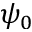<formula> <loc_0><loc_0><loc_500><loc_500>\psi _ { 0 }</formula> 